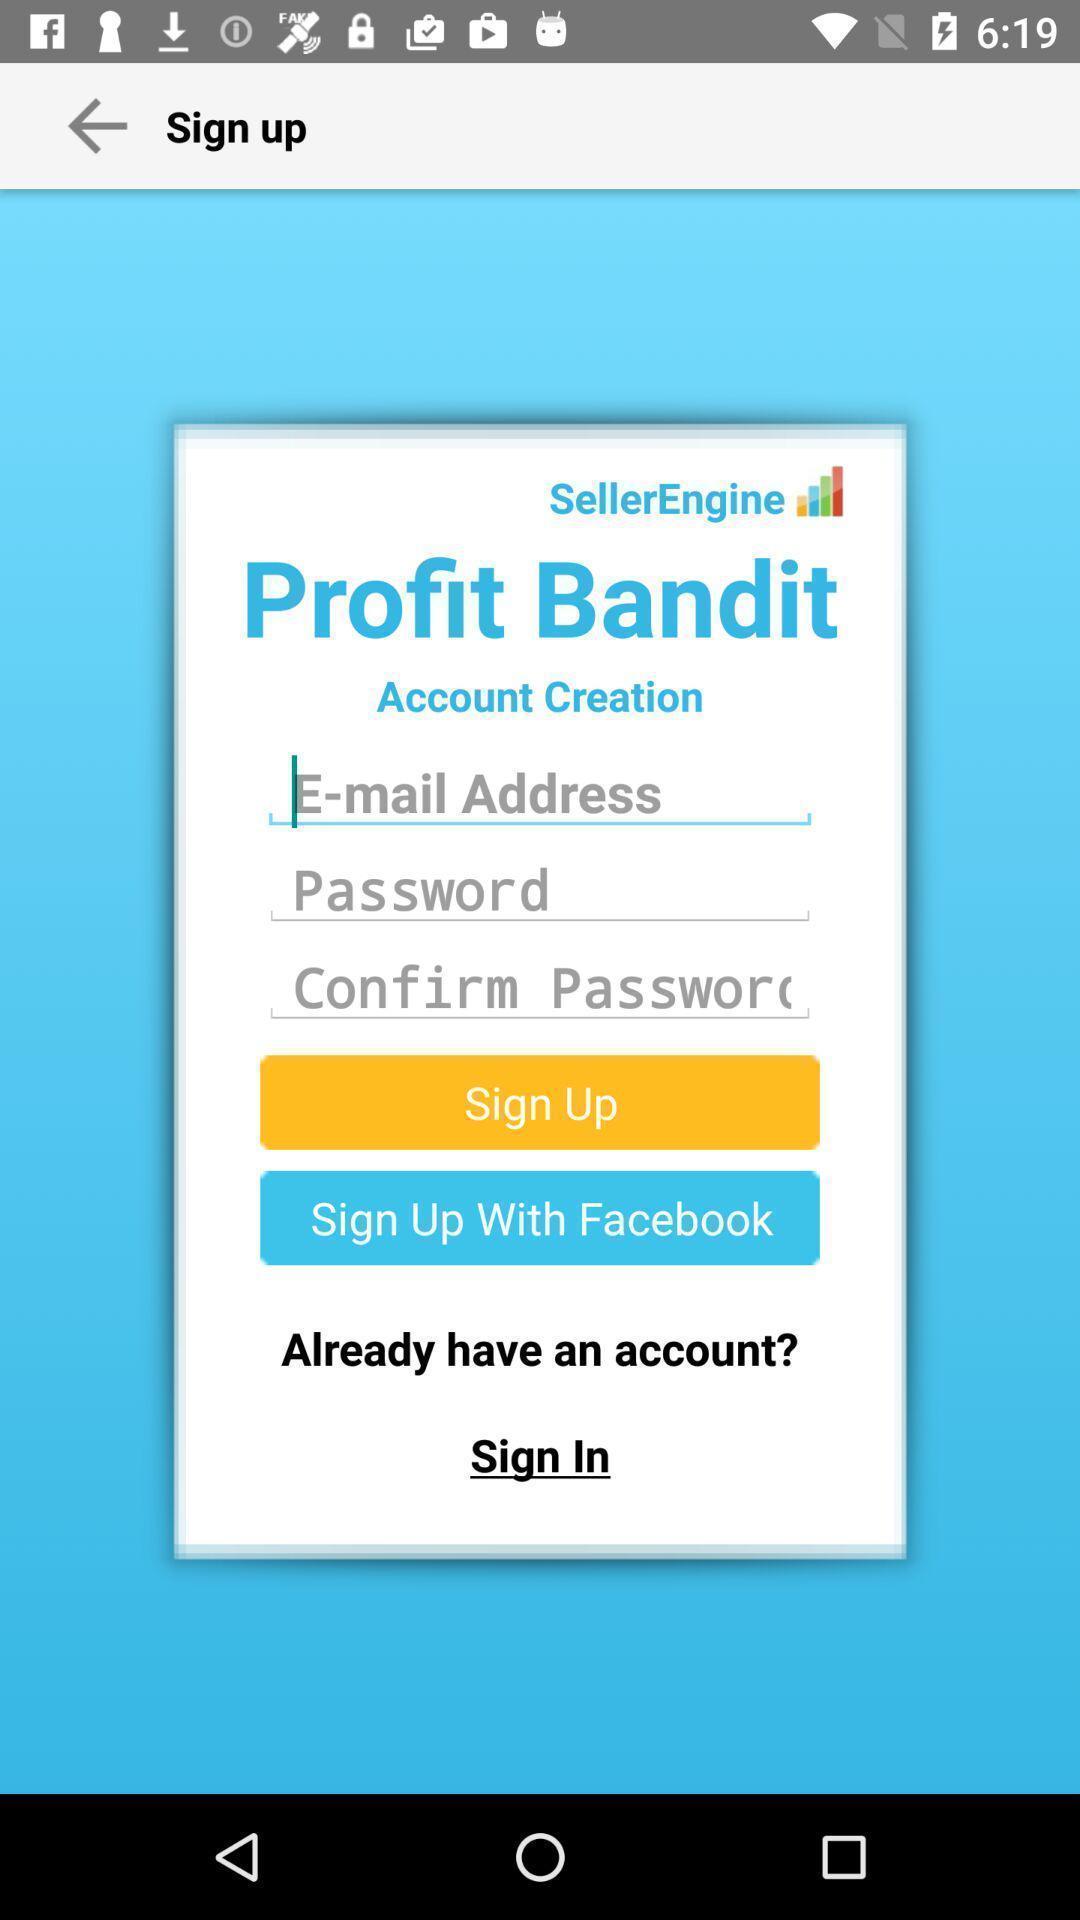What is the overall content of this screenshot? Sign up page of a business app. 